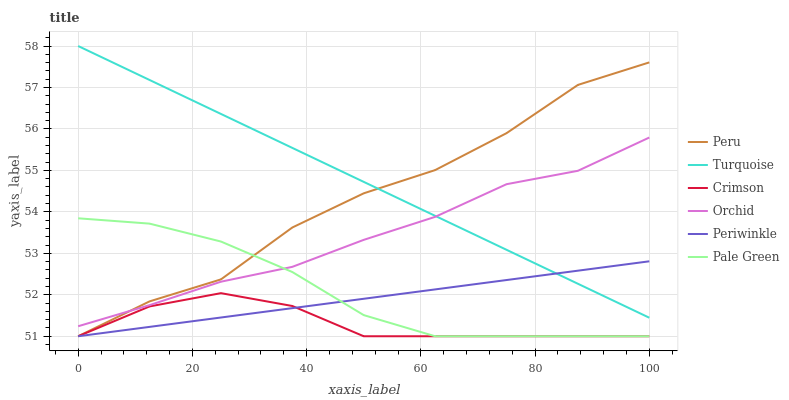Does Pale Green have the minimum area under the curve?
Answer yes or no. No. Does Pale Green have the maximum area under the curve?
Answer yes or no. No. Is Pale Green the smoothest?
Answer yes or no. No. Is Pale Green the roughest?
Answer yes or no. No. Does Orchid have the lowest value?
Answer yes or no. No. Does Pale Green have the highest value?
Answer yes or no. No. Is Crimson less than Turquoise?
Answer yes or no. Yes. Is Orchid greater than Periwinkle?
Answer yes or no. Yes. Does Crimson intersect Turquoise?
Answer yes or no. No. 